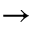<formula> <loc_0><loc_0><loc_500><loc_500>\to</formula> 